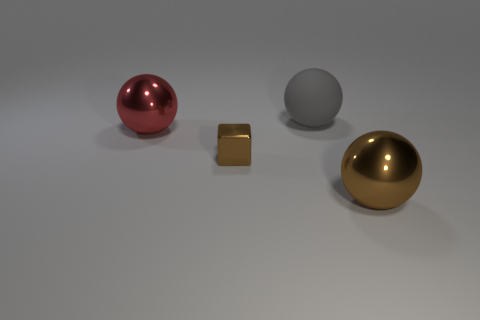Add 2 small metal objects. How many objects exist? 6 Subtract all cubes. How many objects are left? 3 Add 1 large shiny cubes. How many large shiny cubes exist? 1 Subtract 0 cyan blocks. How many objects are left? 4 Subtract all big red balls. Subtract all metal spheres. How many objects are left? 1 Add 1 big brown metallic balls. How many big brown metallic balls are left? 2 